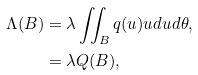Convert formula to latex. <formula><loc_0><loc_0><loc_500><loc_500>\Lambda ( B ) & = \lambda \iint _ { B } q ( u ) u d u d \theta , \\ & = \lambda Q ( B ) ,</formula> 